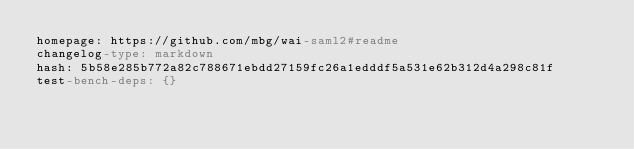<code> <loc_0><loc_0><loc_500><loc_500><_YAML_>homepage: https://github.com/mbg/wai-saml2#readme
changelog-type: markdown
hash: 5b58e285b772a82c788671ebdd27159fc26a1edddf5a531e62b312d4a298c81f
test-bench-deps: {}</code> 